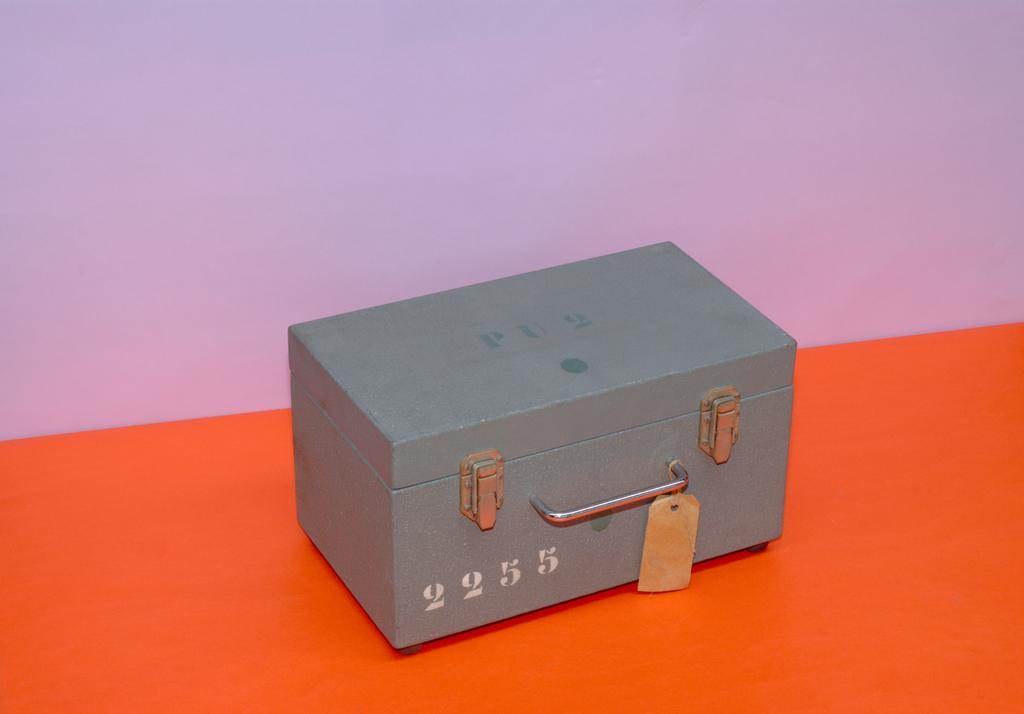<image>
Create a compact narrative representing the image presented. A steellocked gry box with two hinges and a handle in front with the numbers 2255 on the front of the box. 